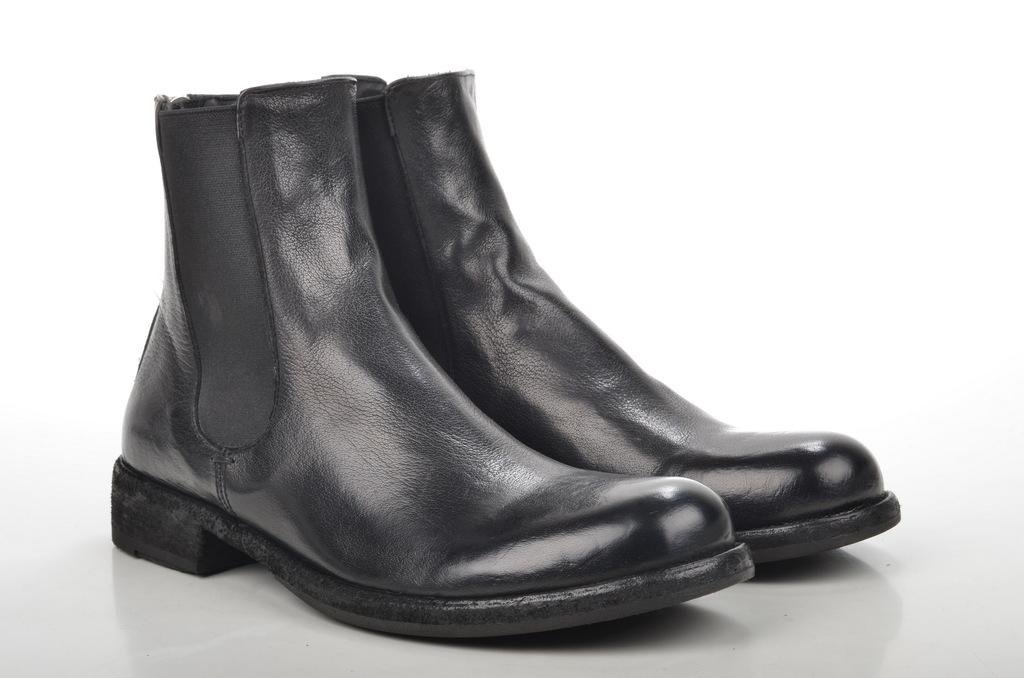What color are the shoes in the image? The shoes in the image are black. Can you see a snail crawling on the shoes in the image? There is no snail present on the shoes in the image. 